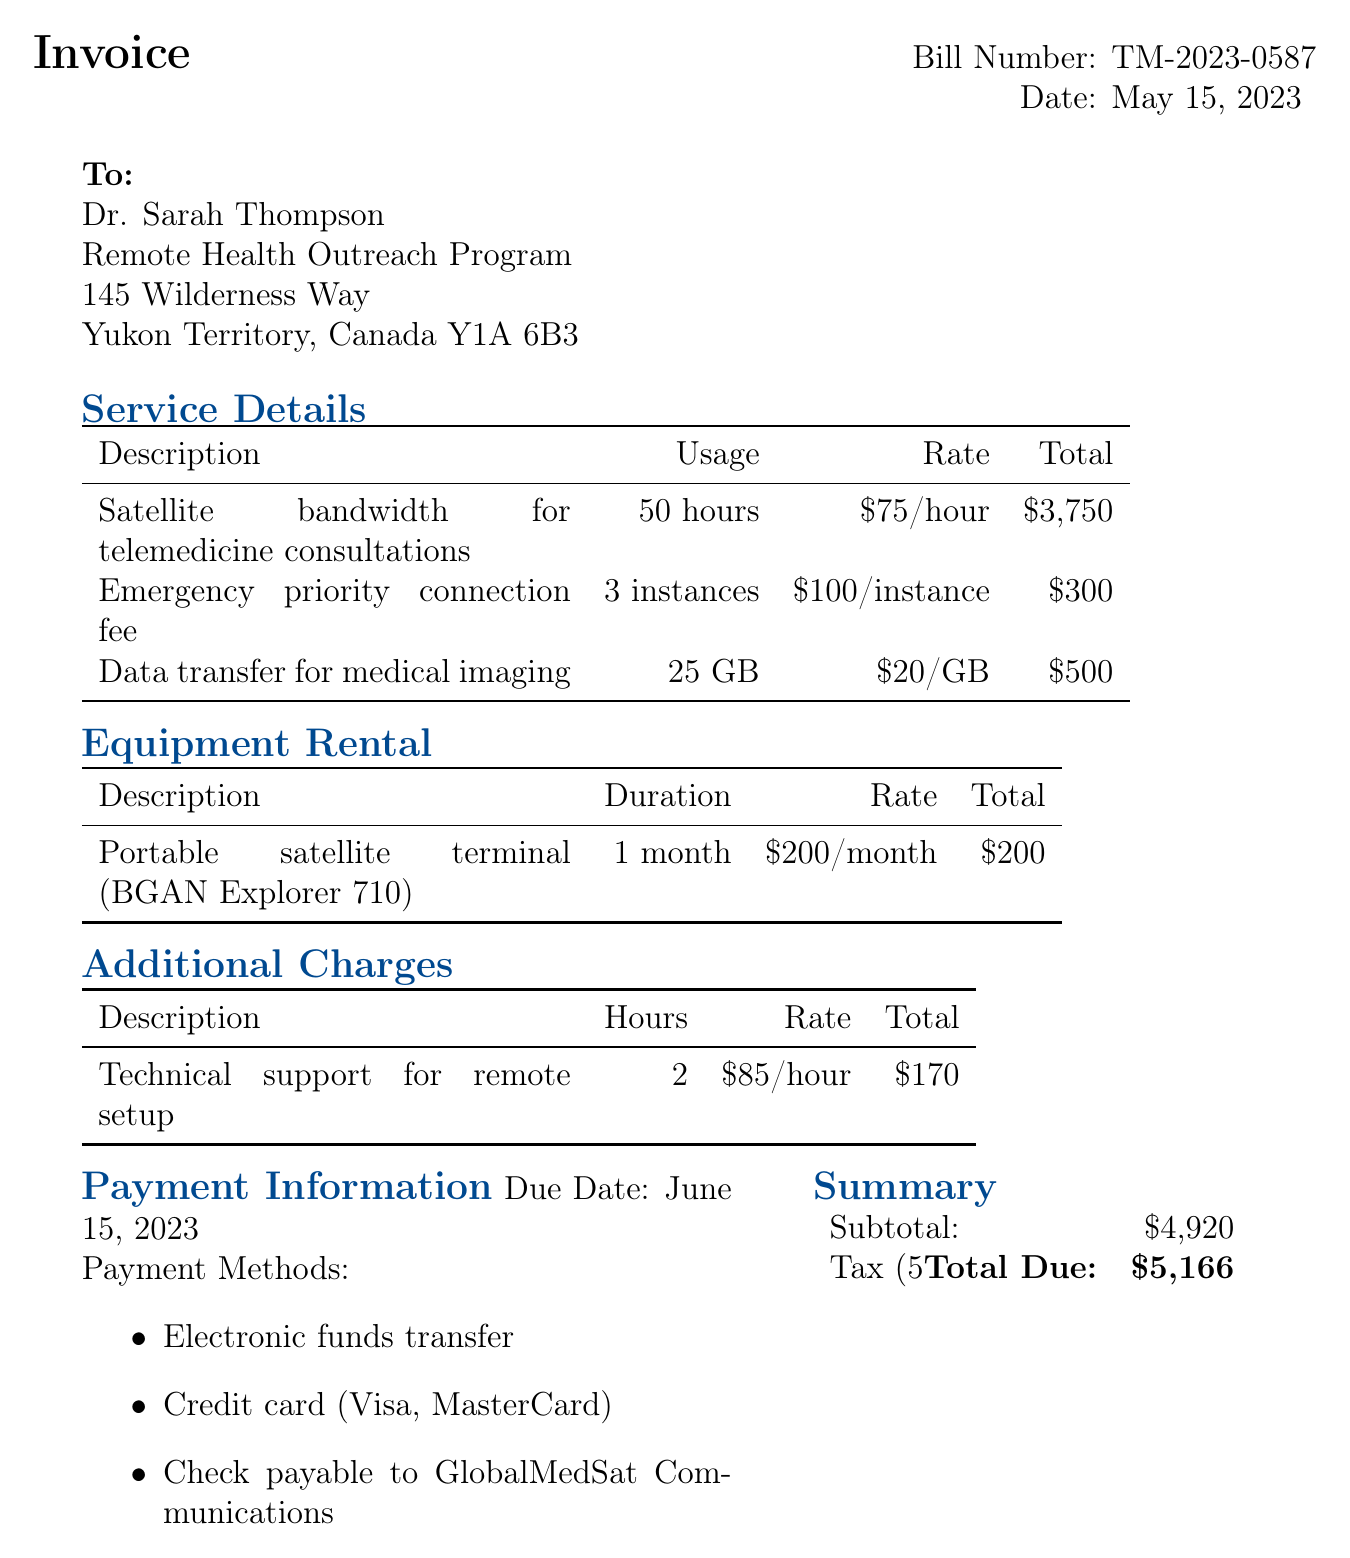What is the invoice number? The invoice number is listed prominently in the document under the "Bill Number" section.
Answer: TM-2023-0587 What date was the bill issued? The date of the bill is mentioned directly below the invoice number.
Answer: May 15, 2023 What is the total amount due? The total due is calculated at the bottom of the summary section of the document.
Answer: $5,166 How many hours of satellite bandwidth were used? The usage of satellite bandwidth is specified in the service details table.
Answer: 50 hours What is the rate for data transfer for medical imaging? The rate for data transfer is presented in the service details table alongside the total.
Answer: $20/GB What is the duration of the portable satellite terminal rental? The rental duration for the portable satellite terminal is stated in the equipment rental section.
Answer: 1 month What is the due date for payment? The payment due date is explicitly mentioned under the payment information section.
Answer: June 15, 2023 How many instances of emergency priority connection were billed? The number of instances is indicated in the service details table.
Answer: 3 instances What is the tax rate applied to the total? The tax rate is explicitly mentioned in the summary section as a percentage.
Answer: 5% GST 